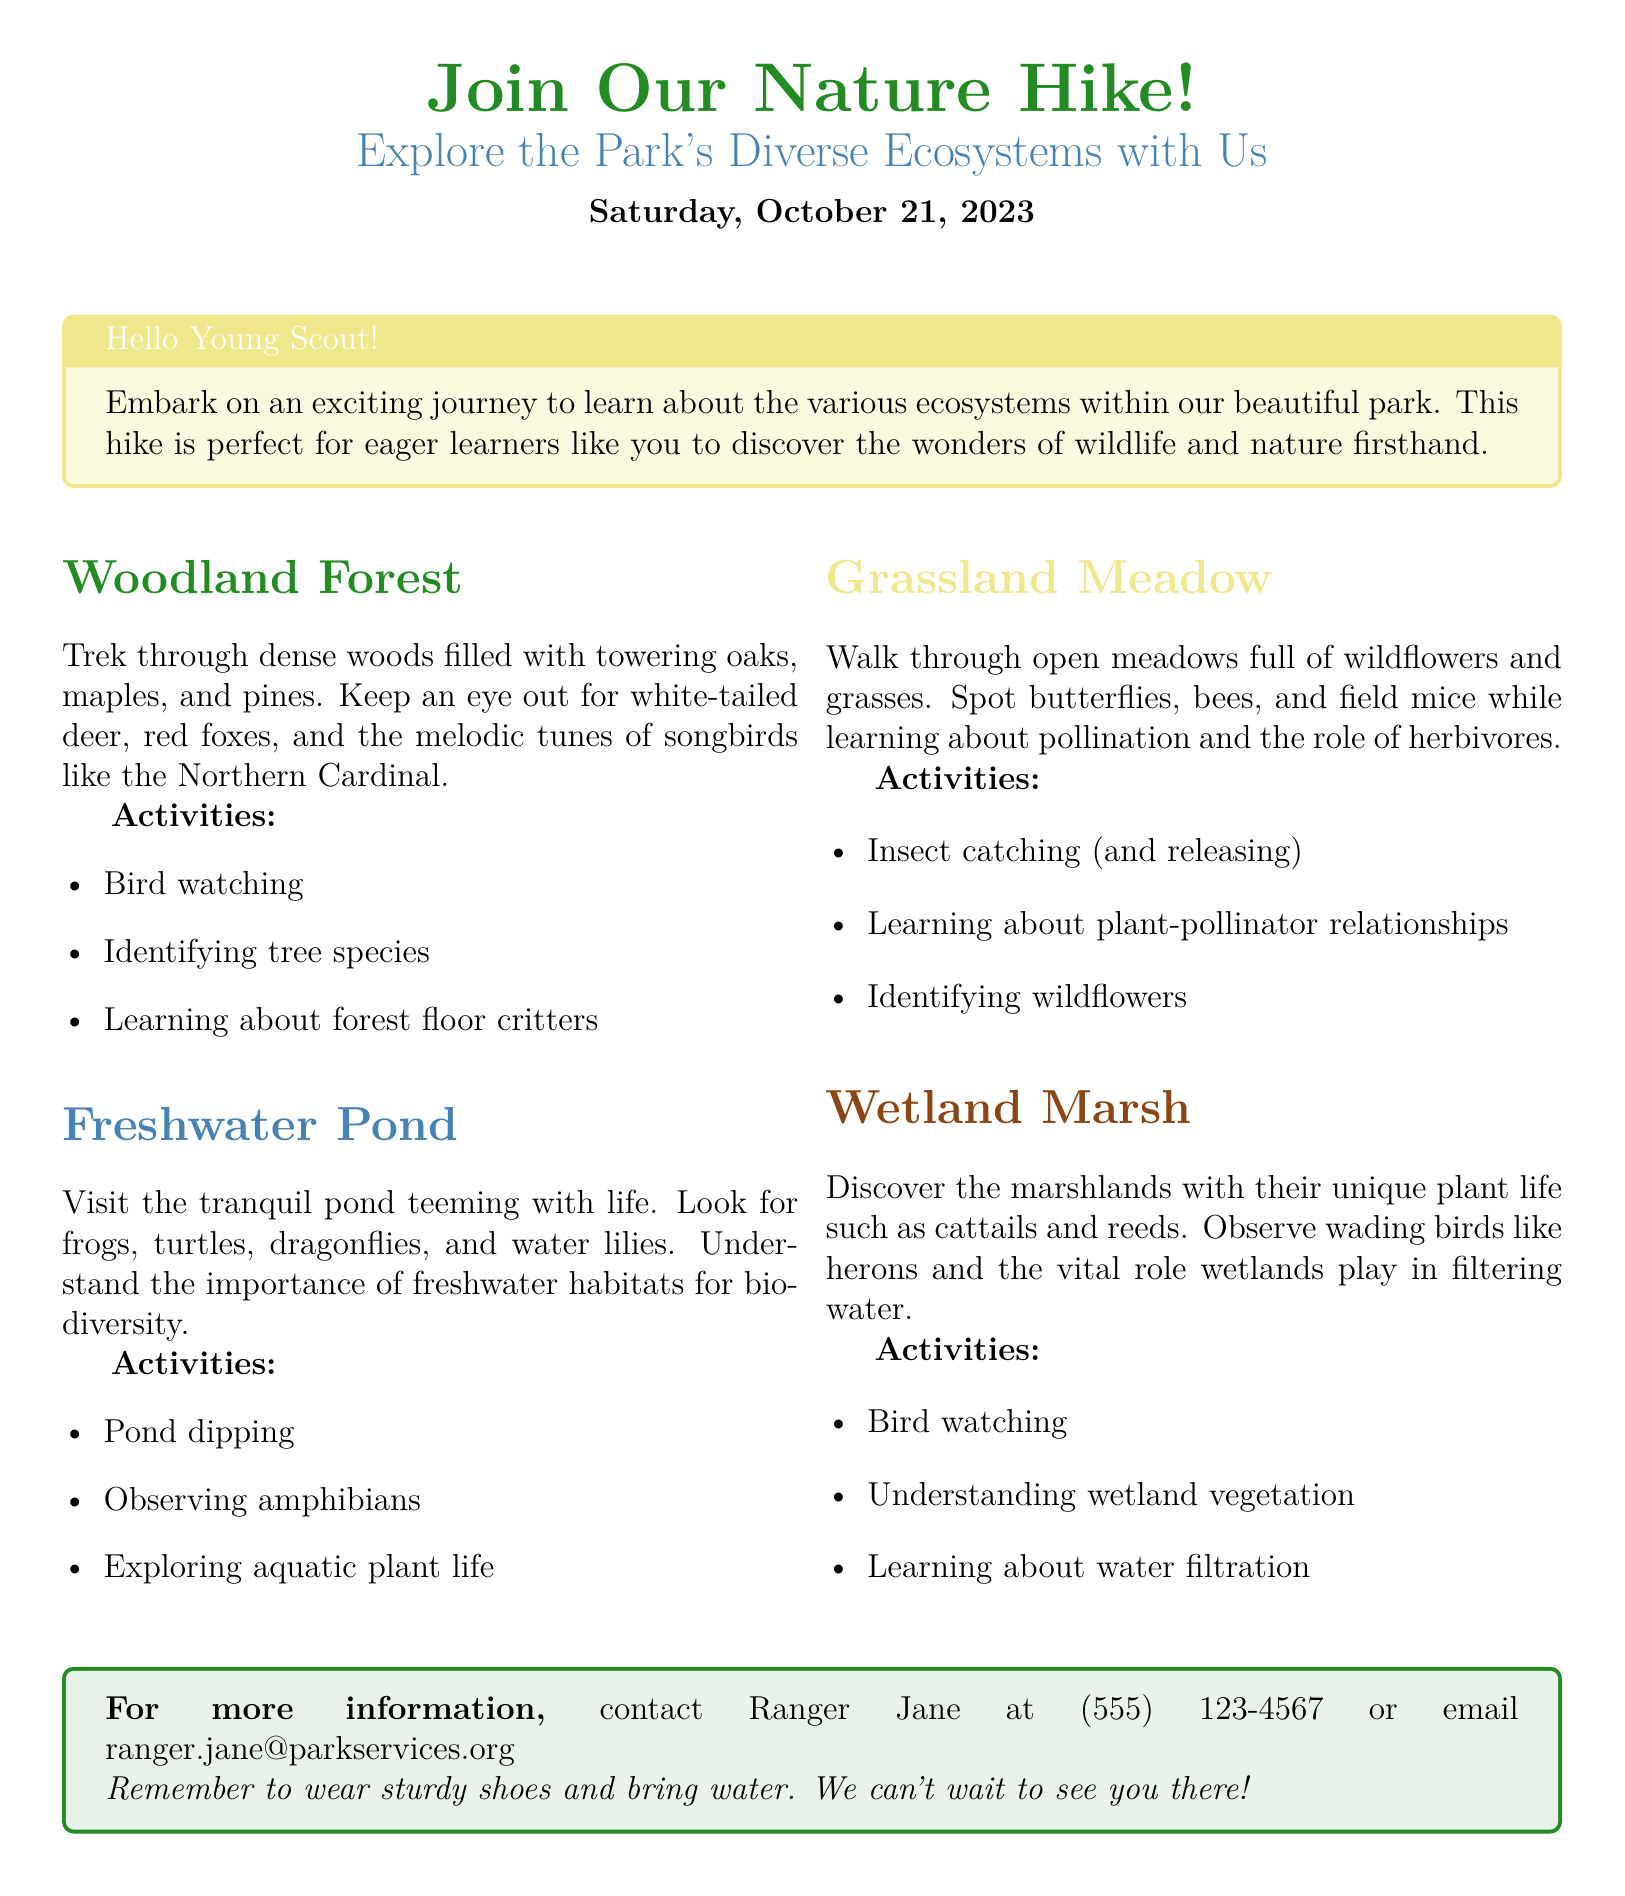What is the date of the nature hike? The date of the nature hike is clearly mentioned in the header section of the document.
Answer: Saturday, October 21, 2023 Who can you contact for more information about the hike? The document specifies a contact person for more information, providing both a name and contact details.
Answer: Ranger Jane What type of ecosystem does the hike include that features frogs and turtles? The description of the ecosystem mentions specific animals that inhabit this area, identifying it by its characteristic life.
Answer: Freshwater Pond What color are the headings of the Woodland Forest section? The document indicates the color of the section headings, which distinguishes each ecosystem area.
Answer: Forest green What activity can you do in the Grassland Meadow? The document lists specific activities associated with each ecosystem, highlighting the interactive aspects of the hike.
Answer: Insect catching (and releasing) How many ecosystems are highlighted in the document? By counting the sections provided in the document, you can determine the number of ecosystems covered in the hike.
Answer: Four What is one amphibian that you might observe during the hike? The document lists specific examples of wildlife present in each ecosystem, including amphibians.
Answer: Frogs What should you wear for the hike? The document includes specific guidance for participants regarding preparation for the hike, focusing on clothing and supplies.
Answer: Sturdy shoes What is one activity in the Wetland Marsh? The document describes activities related to each ecosystem and what participants can learn during their exploration.
Answer: Understanding wetland vegetation 